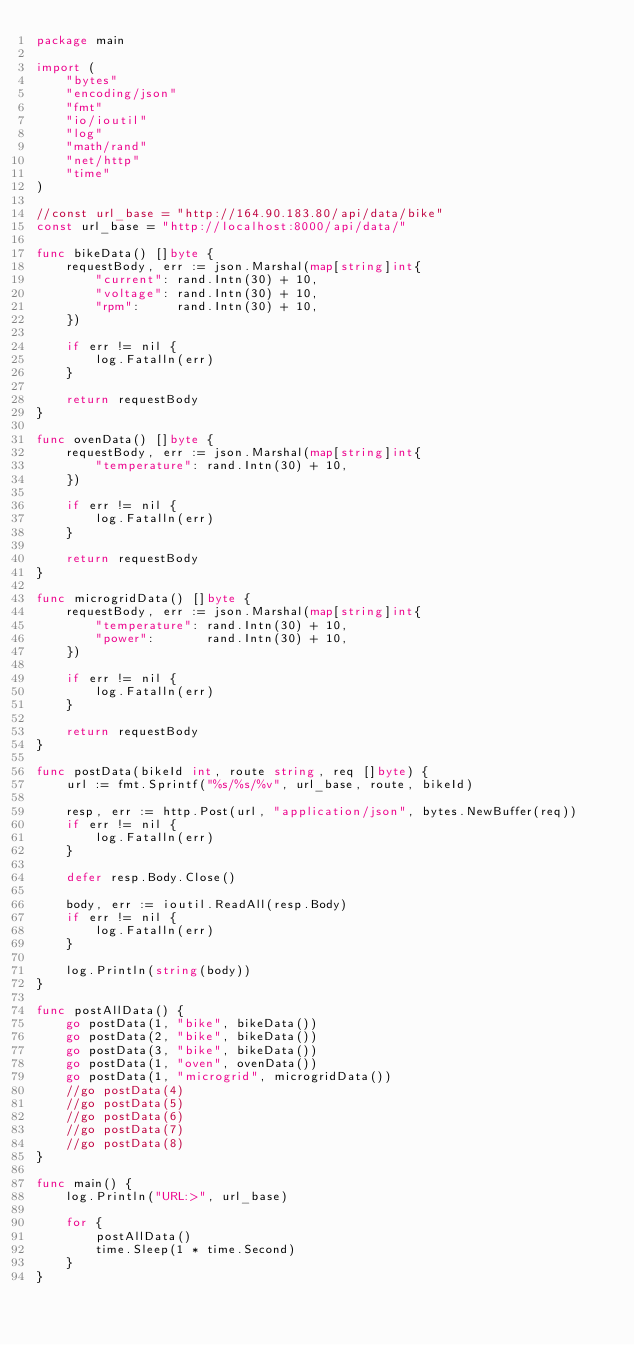Convert code to text. <code><loc_0><loc_0><loc_500><loc_500><_Go_>package main

import (
	"bytes"
	"encoding/json"
	"fmt"
	"io/ioutil"
	"log"
	"math/rand"
	"net/http"
	"time"
)

//const url_base = "http://164.90.183.80/api/data/bike"
const url_base = "http://localhost:8000/api/data/"

func bikeData() []byte {
	requestBody, err := json.Marshal(map[string]int{
		"current": rand.Intn(30) + 10,
		"voltage": rand.Intn(30) + 10,
		"rpm":     rand.Intn(30) + 10,
	})

	if err != nil {
		log.Fatalln(err)
	}

	return requestBody
}

func ovenData() []byte {
	requestBody, err := json.Marshal(map[string]int{
		"temperature": rand.Intn(30) + 10,
	})

	if err != nil {
		log.Fatalln(err)
	}

	return requestBody
}

func microgridData() []byte {
	requestBody, err := json.Marshal(map[string]int{
		"temperature": rand.Intn(30) + 10,
		"power":       rand.Intn(30) + 10,
	})

	if err != nil {
		log.Fatalln(err)
	}

	return requestBody
}

func postData(bikeId int, route string, req []byte) {
	url := fmt.Sprintf("%s/%s/%v", url_base, route, bikeId)

	resp, err := http.Post(url, "application/json", bytes.NewBuffer(req))
	if err != nil {
		log.Fatalln(err)
	}

	defer resp.Body.Close()

	body, err := ioutil.ReadAll(resp.Body)
	if err != nil {
		log.Fatalln(err)
	}

	log.Println(string(body))
}

func postAllData() {
	go postData(1, "bike", bikeData())
	go postData(2, "bike", bikeData())
	go postData(3, "bike", bikeData())
	go postData(1, "oven", ovenData())
	go postData(1, "microgrid", microgridData())
	//go postData(4)
	//go postData(5)
	//go postData(6)
	//go postData(7)
	//go postData(8)
}

func main() {
	log.Println("URL:>", url_base)

	for {
		postAllData()
		time.Sleep(1 * time.Second)
	}
}
</code> 